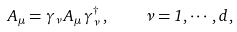<formula> <loc_0><loc_0><loc_500><loc_500>A _ { \mu } = \gamma _ { \nu } \, A _ { \mu } \, \gamma _ { \nu } ^ { \dagger } \, , \quad \nu = 1 , \cdots , d \, ,</formula> 